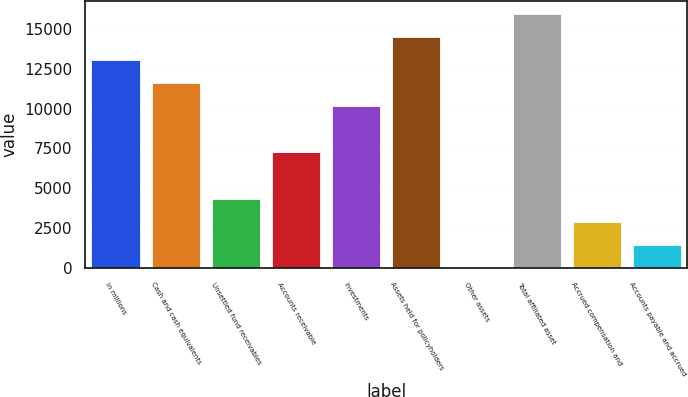<chart> <loc_0><loc_0><loc_500><loc_500><bar_chart><fcel>in millions<fcel>Cash and cash equivalents<fcel>Unsettled fund receivables<fcel>Accounts receivable<fcel>Investments<fcel>Assets held for policyholders<fcel>Other assets<fcel>Total affiliated asset<fcel>Accrued compensation and<fcel>Accounts payable and accrued<nl><fcel>13052.1<fcel>11602.9<fcel>4356.83<fcel>7255.25<fcel>10153.7<fcel>14501.3<fcel>9.2<fcel>15950.5<fcel>2907.62<fcel>1458.41<nl></chart> 